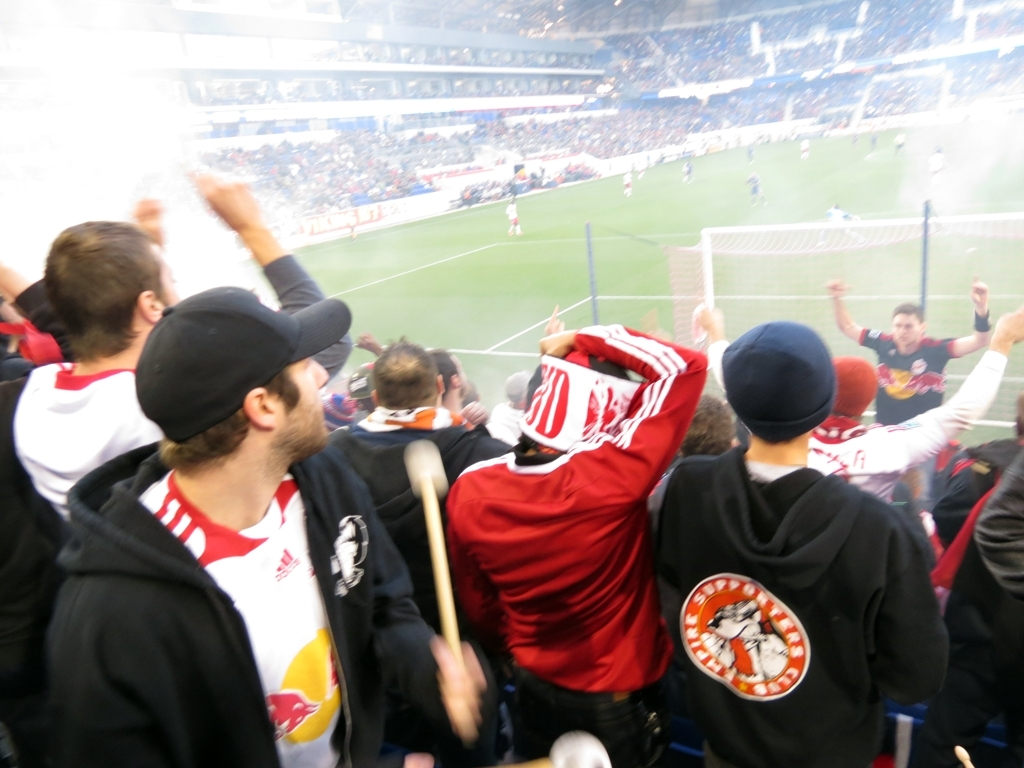What might be happening outside of this frame? Outside of this frame, it’s likely that more fans are exhibiting similar behaviors of enthusiasm, with their attention probably fixated on the field. Players could be regrouping or celebrating, and the overall stadium is likely echoing with the sounds of cheers, commentary, and general excitement of the sporting event. 